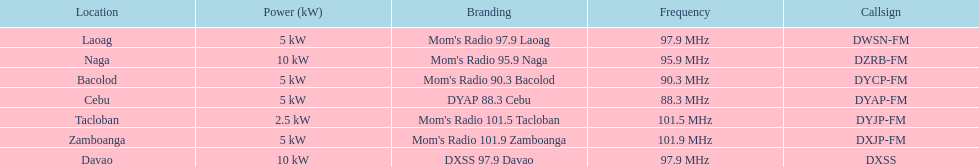What is the last location on this chart? Davao. Give me the full table as a dictionary. {'header': ['Location', 'Power (kW)', 'Branding', 'Frequency', 'Callsign'], 'rows': [['Laoag', '5\xa0kW', "Mom's Radio 97.9 Laoag", '97.9\xa0MHz', 'DWSN-FM'], ['Naga', '10\xa0kW', "Mom's Radio 95.9 Naga", '95.9\xa0MHz', 'DZRB-FM'], ['Bacolod', '5\xa0kW', "Mom's Radio 90.3 Bacolod", '90.3\xa0MHz', 'DYCP-FM'], ['Cebu', '5\xa0kW', 'DYAP 88.3 Cebu', '88.3\xa0MHz', 'DYAP-FM'], ['Tacloban', '2.5\xa0kW', "Mom's Radio 101.5 Tacloban", '101.5\xa0MHz', 'DYJP-FM'], ['Zamboanga', '5\xa0kW', "Mom's Radio 101.9 Zamboanga", '101.9\xa0MHz', 'DXJP-FM'], ['Davao', '10\xa0kW', 'DXSS 97.9 Davao', '97.9\xa0MHz', 'DXSS']]} 